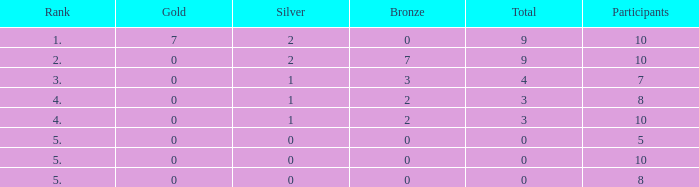What is listed as the highest Rank that has a Gold that's larger than 0, and Participants that's smaller than 10? None. 